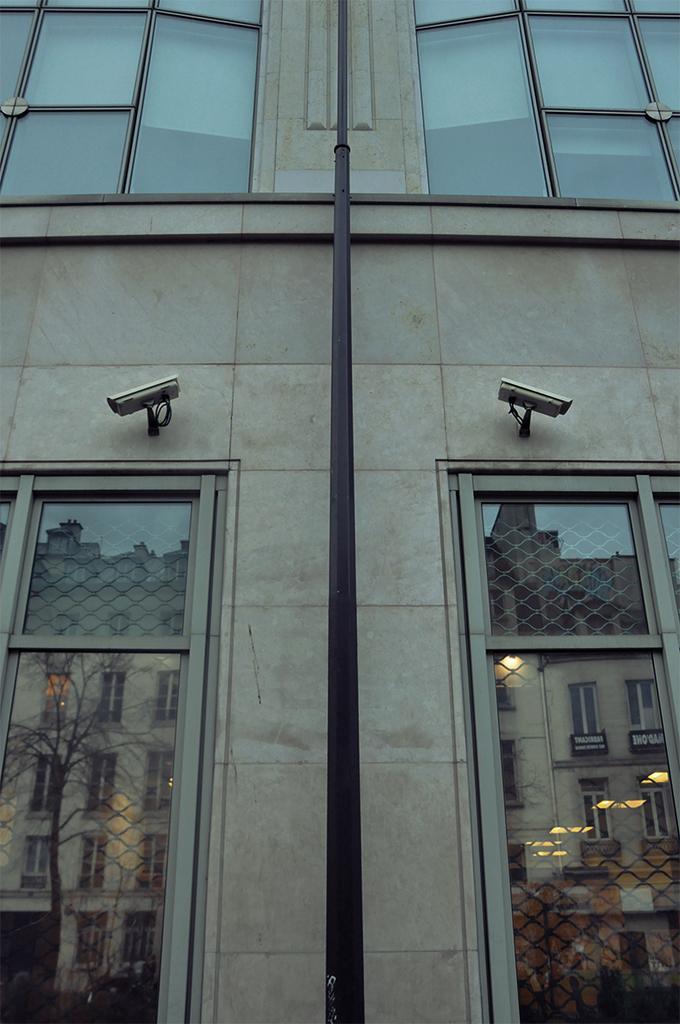Can you describe this image briefly? In this image I can see the wall, few cctv cameras, glass windows and here in these glasses I can see reflection of a building. I can also see a black colour pole over here. 